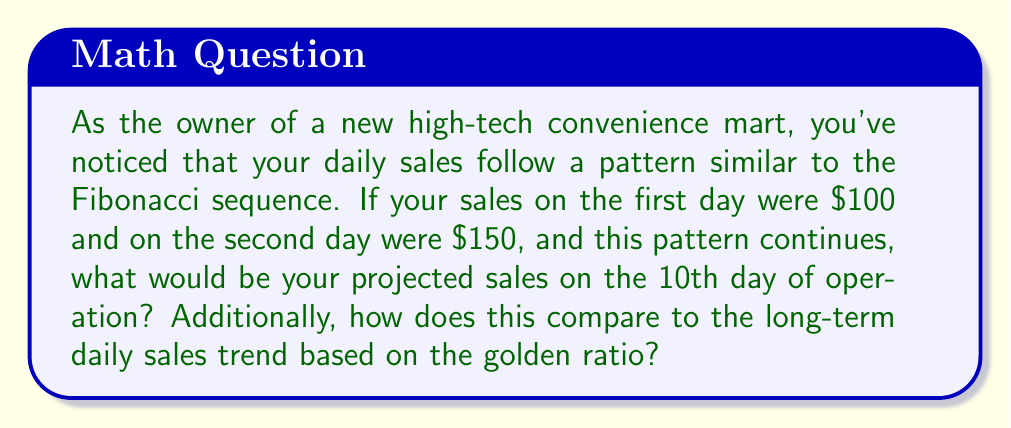Help me with this question. Let's approach this step-by-step:

1) First, let's recall the Fibonacci sequence:
   $$F_n = F_{n-1} + F_{n-2}$$
   where $F_n$ is the nth term in the sequence.

2) Given:
   Day 1 sales: $F_1 = $100
   Day 2 sales: $F_2 = $150

3) Let's calculate the next few terms:
   Day 3: $F_3 = F_2 + F_1 = 150 + 100 = $250
   Day 4: $F_4 = F_3 + F_2 = 250 + 150 = $400
   Day 5: $F_5 = F_4 + F_3 = 400 + 250 = $650

4) Continuing this pattern, we can find the 10th term:
   $F_6 = 1050$
   $F_7 = 1700$
   $F_8 = 2750$
   $F_9 = 4450$
   $F_{10} = 7200$

5) Therefore, the projected sales on the 10th day would be $7200.

6) Now, let's consider the long-term trend based on the golden ratio.
   The golden ratio, $\phi$, is approximately 1.618034...

7) In the long term, the ratio between consecutive Fibonacci numbers approaches $\phi$:
   $$\lim_{n \to \infty} \frac{F_{n+1}}{F_n} = \phi$$

8) We can calculate the ratio of our 10th day to 9th day sales:
   $$\frac{F_{10}}{F_9} = \frac{7200}{4450} \approx 1.6180$$

9) This ratio is very close to $\phi$, indicating that our sales are already approaching the long-term trend governed by the golden ratio.

10) In the very long term, we would expect each day's sales to be approximately 1.618034 times the previous day's sales.
Answer: $7200; ratio approaches 1.618034 